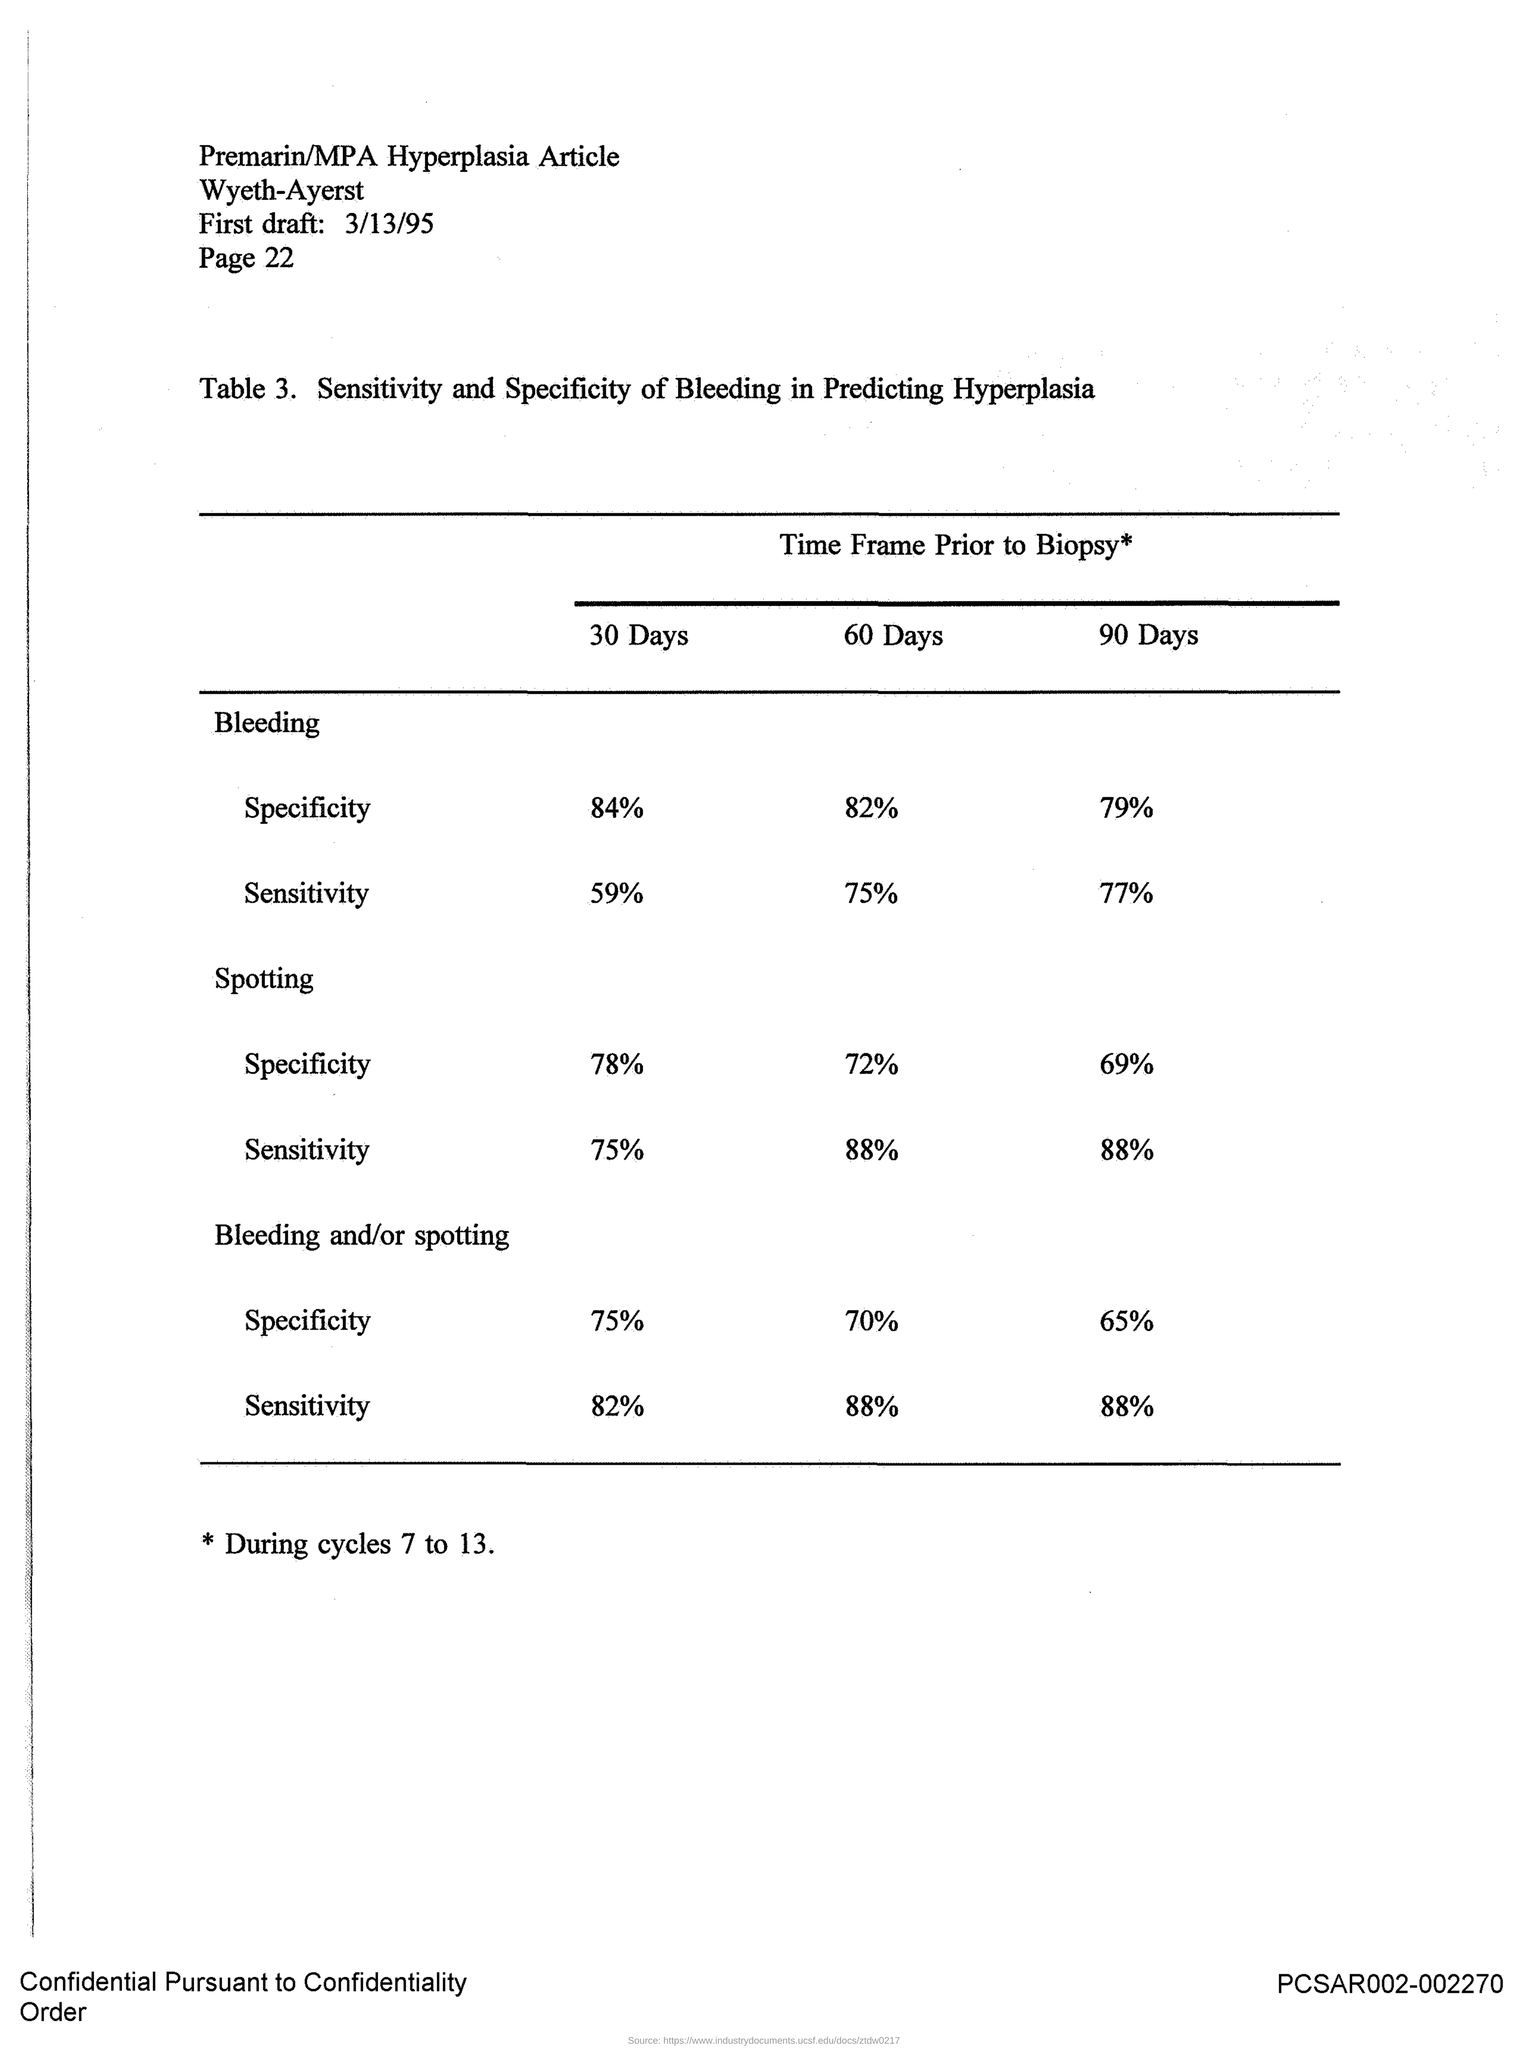When is the first draft?
Keep it short and to the point. 3/13/95. What is the page?
Your answer should be very brief. 22. 